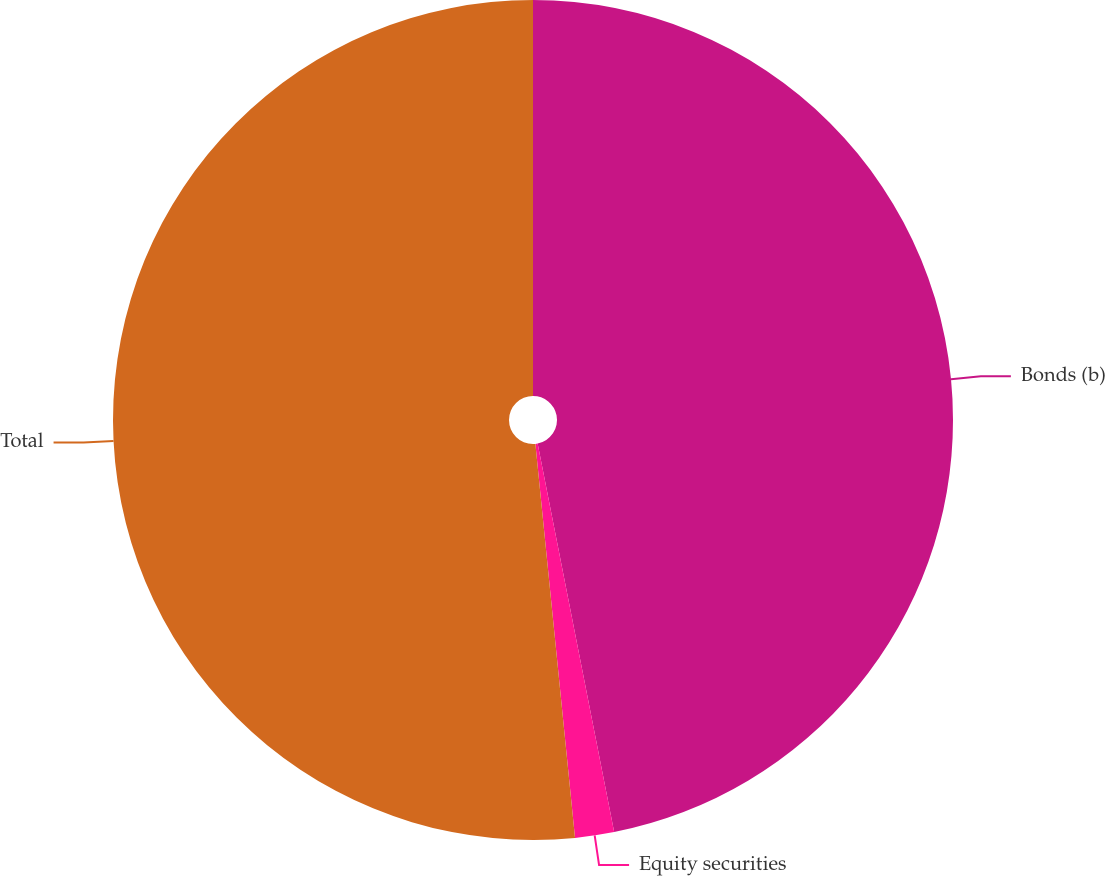Convert chart. <chart><loc_0><loc_0><loc_500><loc_500><pie_chart><fcel>Bonds (b)<fcel>Equity securities<fcel>Total<nl><fcel>46.9%<fcel>1.5%<fcel>51.59%<nl></chart> 